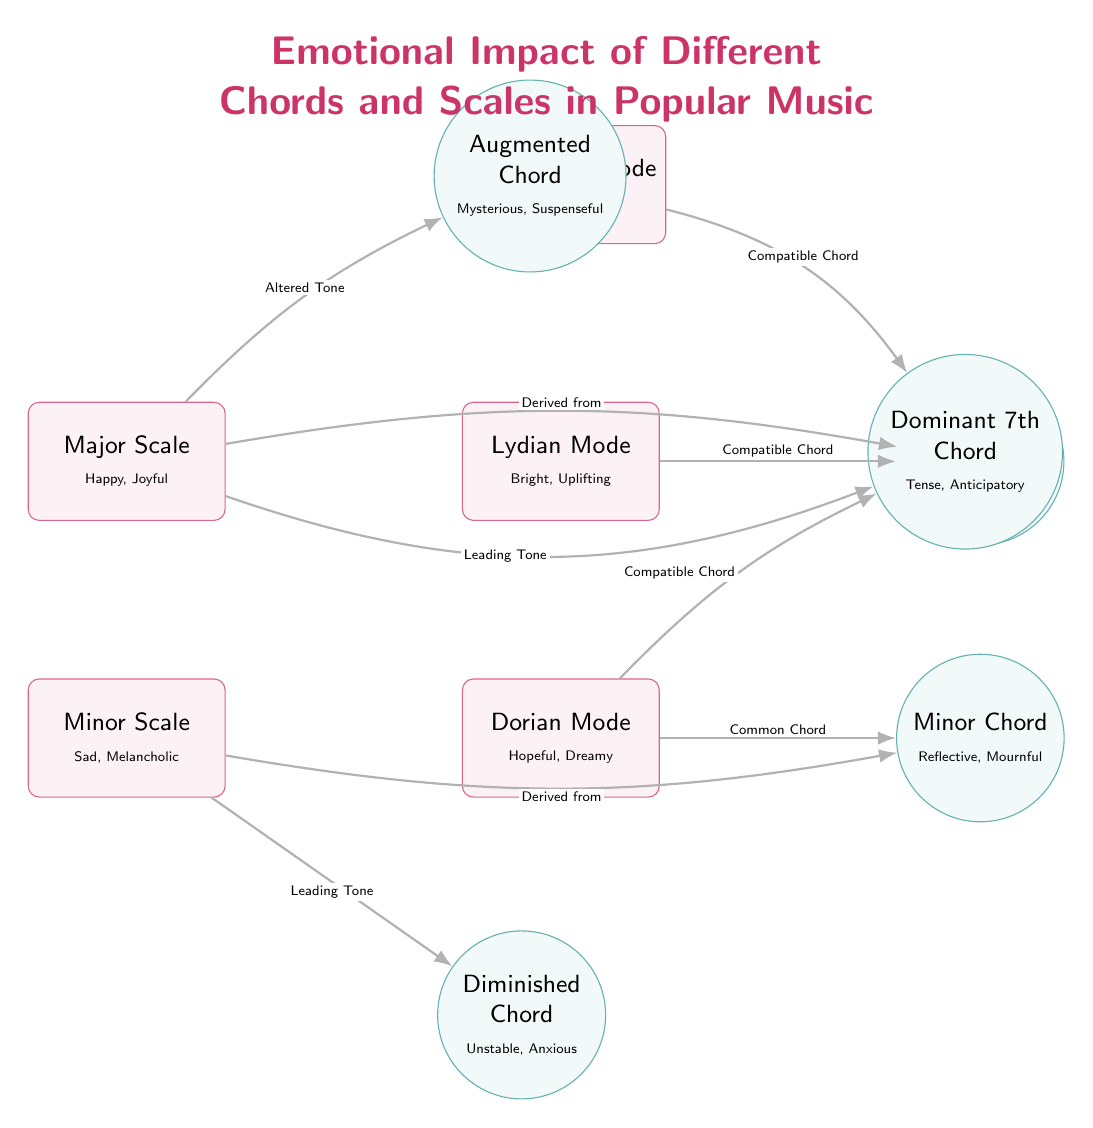What emotional impact is associated with the Major Scale? The Major Scale has "Happy, Joyful" as its emotional impact, which is stated directly below the scale name in the diagram.
Answer: Happy, Joyful How many chords are depicted in the diagram? There are five chords illustrated in the diagram: Major Chord, Minor Chord, Dominant 7th Chord, Diminished Chord, and Augmented Chord. This can be counted by looking at the chord nodes present.
Answer: Five What scale is associated with the emotion "Sad, Melancholic"? The scale associated with "Sad, Melancholic" is the Minor Scale, which is labeled accordingly in the diagram.
Answer: Minor Scale Which chord is a common chord for the Dorian Mode? The Minor Chord is indicated as a common chord for the Dorian Mode in the diagram. This relationship is shown with an arrow from the Dorian Mode to the Minor Chord.
Answer: Minor Chord What is the emotional impact of the Diminished Chord? The Diminished Chord is described as "Unstable, Anxious", which is given directly next to the chord's label in the diagram.
Answer: Unstable, Anxious Which scale has an "Altered Tone" relationship with an Augmented Chord? The Major Scale has an "Altered Tone" relationship with the Augmented Chord, as denoted by the labeled arrow in the diagram connecting these two elements.
Answer: Major Scale What type of emotional impact is described for the Major Chord? The emotional impact of the Major Chord is described as "Bright, Content" which is explicitly stated next to the chord in the diagram.
Answer: Bright, Content Which chord is derived from the Minor Scale? The Minor Chord is derived from the Minor Scale, as shown by the labeled arrow pointing from the Minor Scale to the Minor Chord.
Answer: Minor Chord What is the relationship between the Major Scale and the Dominant 7th Chord? The Major Scale has a "Leading Tone" relationship with the Dominant 7th Chord, as indicated by the arrow in the diagram.
Answer: Leading Tone 